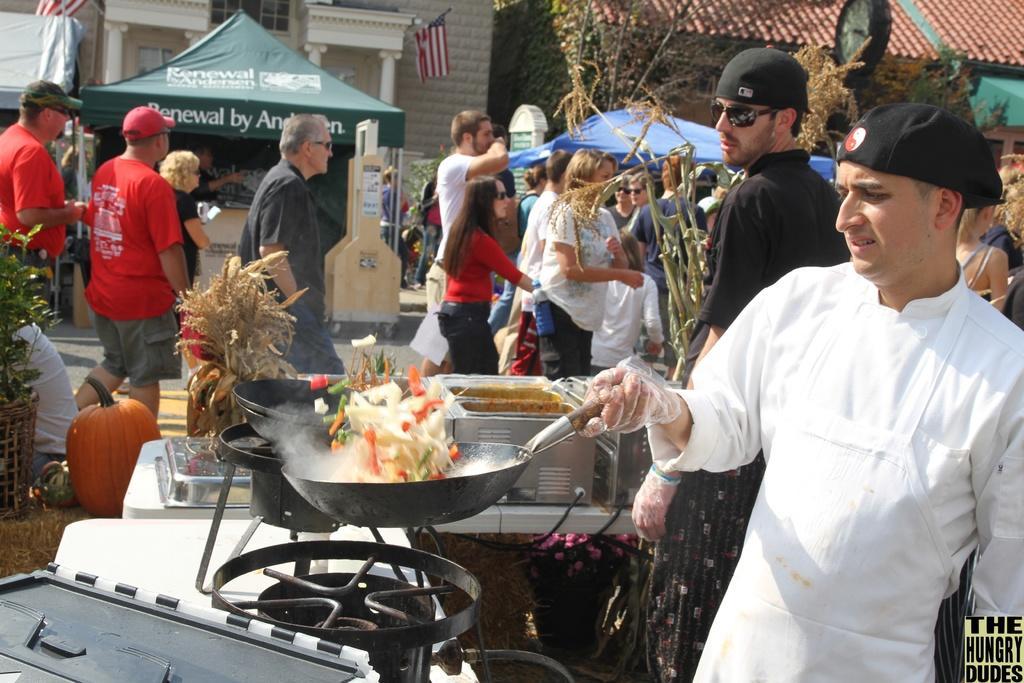Describe this image in one or two sentences. In this image there are group of persons walking on the road, there are tents, there is text on the tent, there are persons truncated towards the right of the image, there is a person holding a wok, there are objects on the table, there is an object truncated towards the bottom of the image, there is text towards the bottom of the image, there is a plant truncated towards the left of the image, there is a pumpkin on the ground, there is a person truncated towards the left of the image, there are flags, there is the wall, there is roof truncated towards the top of the image. 